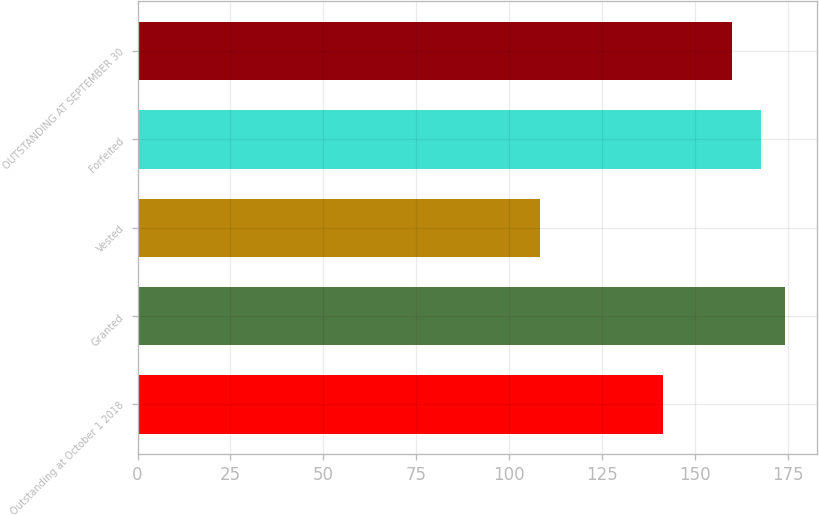<chart> <loc_0><loc_0><loc_500><loc_500><bar_chart><fcel>Outstanding at October 1 2018<fcel>Granted<fcel>Vested<fcel>Forfeited<fcel>OUTSTANDING AT SEPTEMBER 30<nl><fcel>141.35<fcel>174.18<fcel>108.4<fcel>167.94<fcel>160.14<nl></chart> 